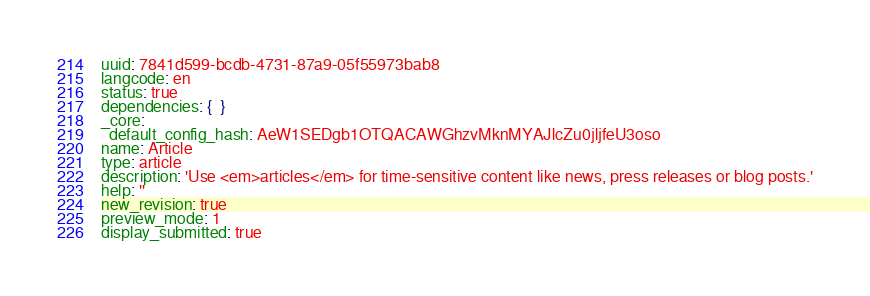<code> <loc_0><loc_0><loc_500><loc_500><_YAML_>uuid: 7841d599-bcdb-4731-87a9-05f55973bab8
langcode: en
status: true
dependencies: {  }
_core:
  default_config_hash: AeW1SEDgb1OTQACAWGhzvMknMYAJlcZu0jljfeU3oso
name: Article
type: article
description: 'Use <em>articles</em> for time-sensitive content like news, press releases or blog posts.'
help: ''
new_revision: true
preview_mode: 1
display_submitted: true
</code> 